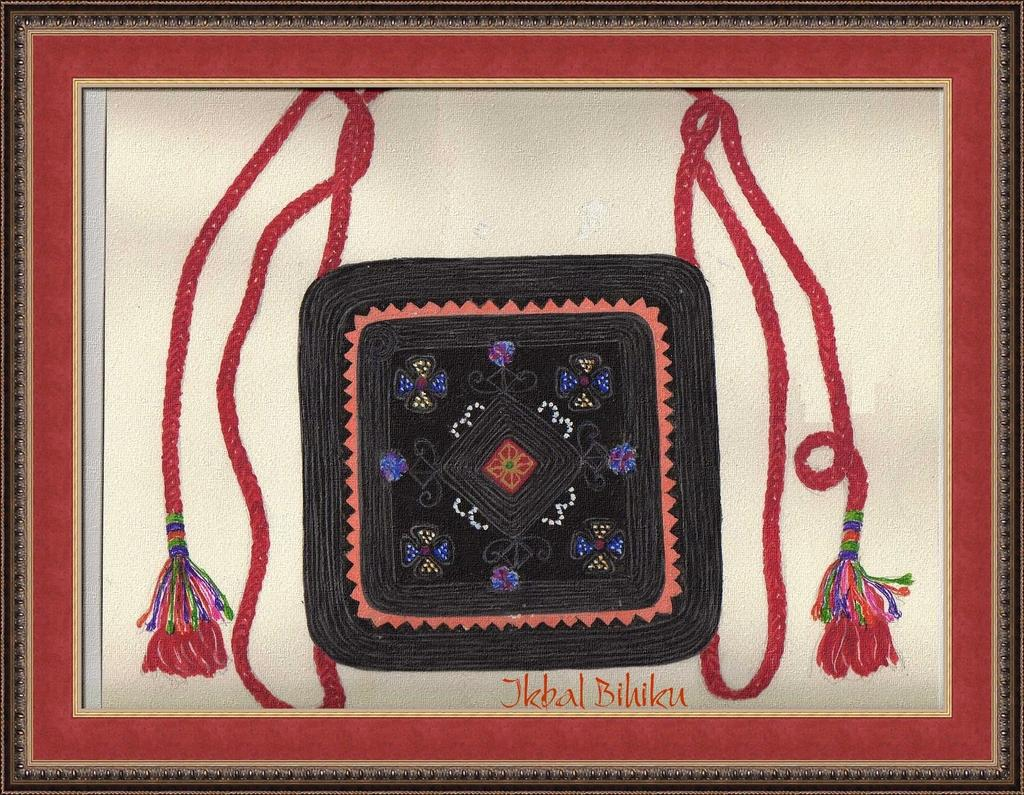<image>
Summarize the visual content of the image. Framed photo of a wallet and the name "Jkbal Bihiku". 